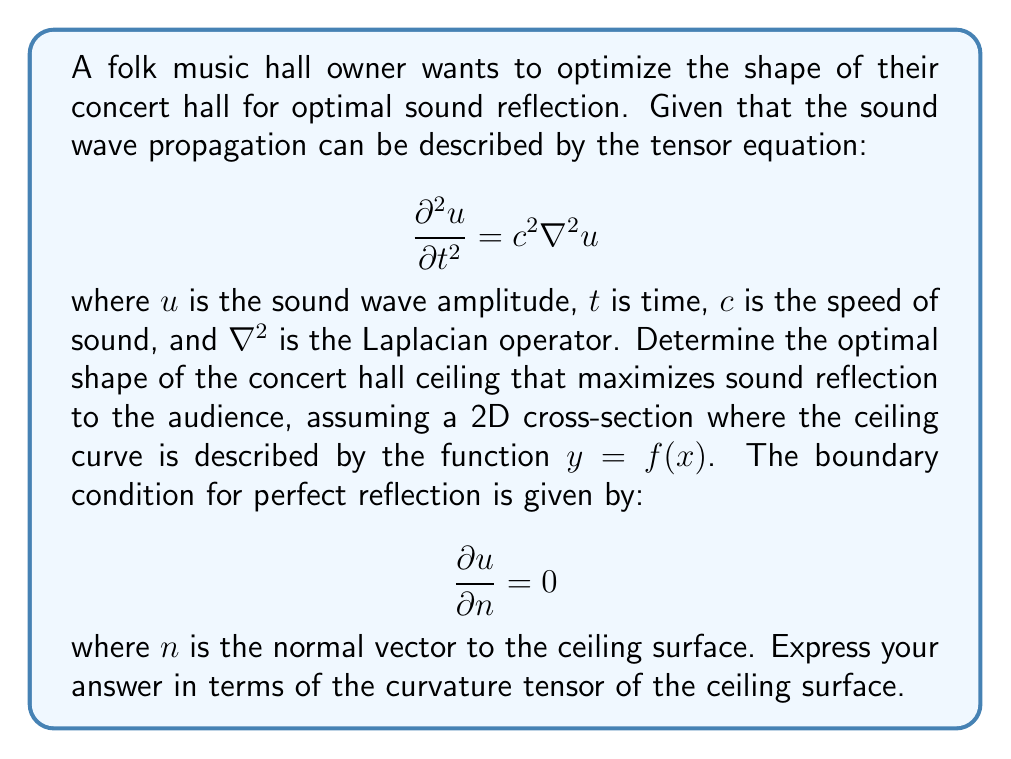Provide a solution to this math problem. To solve this problem, we'll follow these steps:

1) First, we need to understand that the optimal shape for sound reflection is one that focuses the sound waves towards the audience. This is achieved when the ceiling acts as a parabolic reflector.

2) The normal vector to the ceiling surface can be expressed as:

   $$\vec{n} = \frac{(-f'(x), 1)}{\sqrt{1 + (f'(x))^2}}$$

3) The boundary condition for perfect reflection can be written as:

   $$\frac{\partial u}{\partial x} \cdot (-f'(x)) + \frac{\partial u}{\partial y} = 0$$

4) The curvature of the ceiling surface is given by the curvature tensor, which in 2D reduces to a scalar value:

   $$\kappa = \frac{f''(x)}{(1 + (f'(x))^2)^{3/2}}$$

5) For a parabolic reflector, the curvature should be constant. Let's call this constant $K$. Then:

   $$\frac{f''(x)}{(1 + (f'(x))^2)^{3/2}} = K$$

6) Solving this differential equation, we get:

   $$f(x) = \frac{K}{2}x^2 + C$$

   where $C$ is a constant of integration.

7) This equation describes a parabola, which is indeed the optimal shape for focusing sound waves.

8) The optimal shape is thus characterized by a constant curvature tensor $K$, where the magnitude of $K$ determines how quickly the sound waves are focused.
Answer: The optimal ceiling shape has a constant curvature tensor $K$, described by $y = \frac{K}{2}x^2 + C$. 